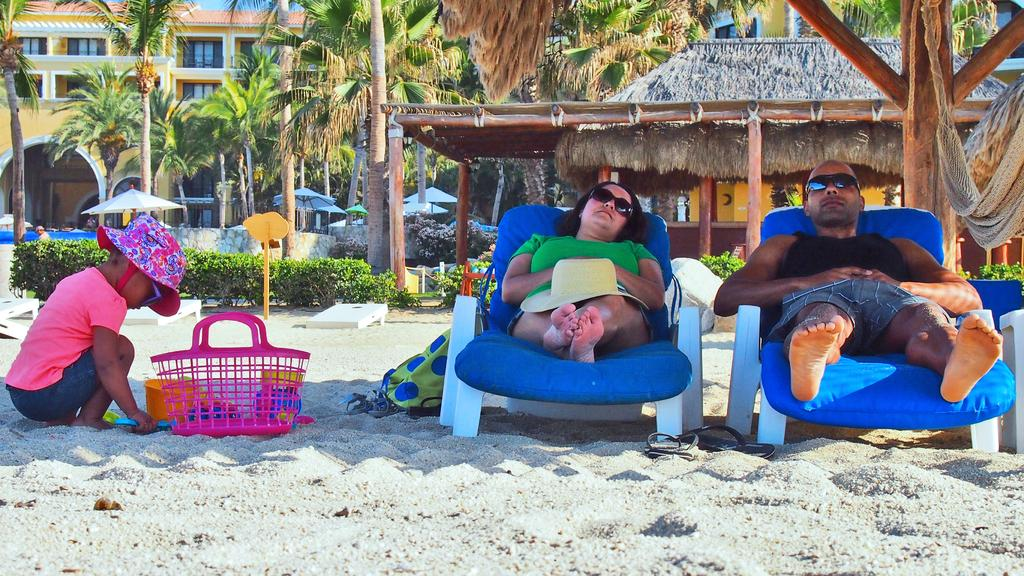How many people are present in the image? There are people in the image, but the exact number is not specified. What type of structures can be seen in the image? There are sheds, trees, sand, a basket, buildings, and plants in the image. Can you describe the landscape in the image? The image features a combination of natural elements like trees and sand, as well as man-made structures like sheds and buildings. What might be used for carrying items in the image? There is a basket in the image, which could be used for carrying items. What other unspecified objects are present in the image? There are other unspecified objects in the image, but their nature is not described. What type of flag is being waved by the horses in the image? There are no horses or flags present in the image. What type of apparel are the people wearing in the image? The facts provided do not mention the apparel worn by the people in the image. 